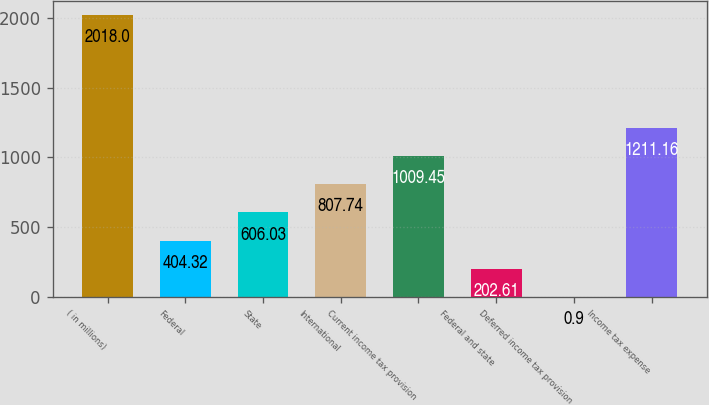<chart> <loc_0><loc_0><loc_500><loc_500><bar_chart><fcel>( in millions)<fcel>Federal<fcel>State<fcel>International<fcel>Current income tax provision<fcel>Federal and state<fcel>Deferred income tax provision<fcel>Income tax expense<nl><fcel>2018<fcel>404.32<fcel>606.03<fcel>807.74<fcel>1009.45<fcel>202.61<fcel>0.9<fcel>1211.16<nl></chart> 